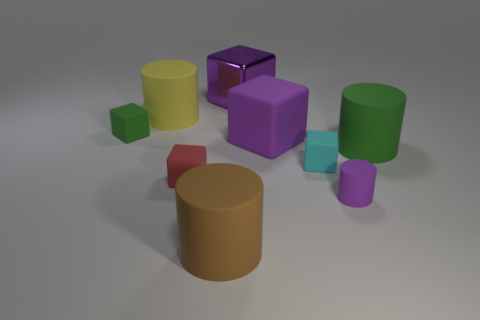What can you infer about the lighting and shadows visible in the scene? The scene is illuminated by a diffused light source that appears to be coming from the right, judging by the gentle shadows cast by the objects on the left. This soft lighting creates subtle shadows and gives the objects a sense of dimension while enhancing their matte and reflective surfaces. The shadows are elongated yet soft at the edges, suggesting that the light source is not extremely close but still has a significant presence. 